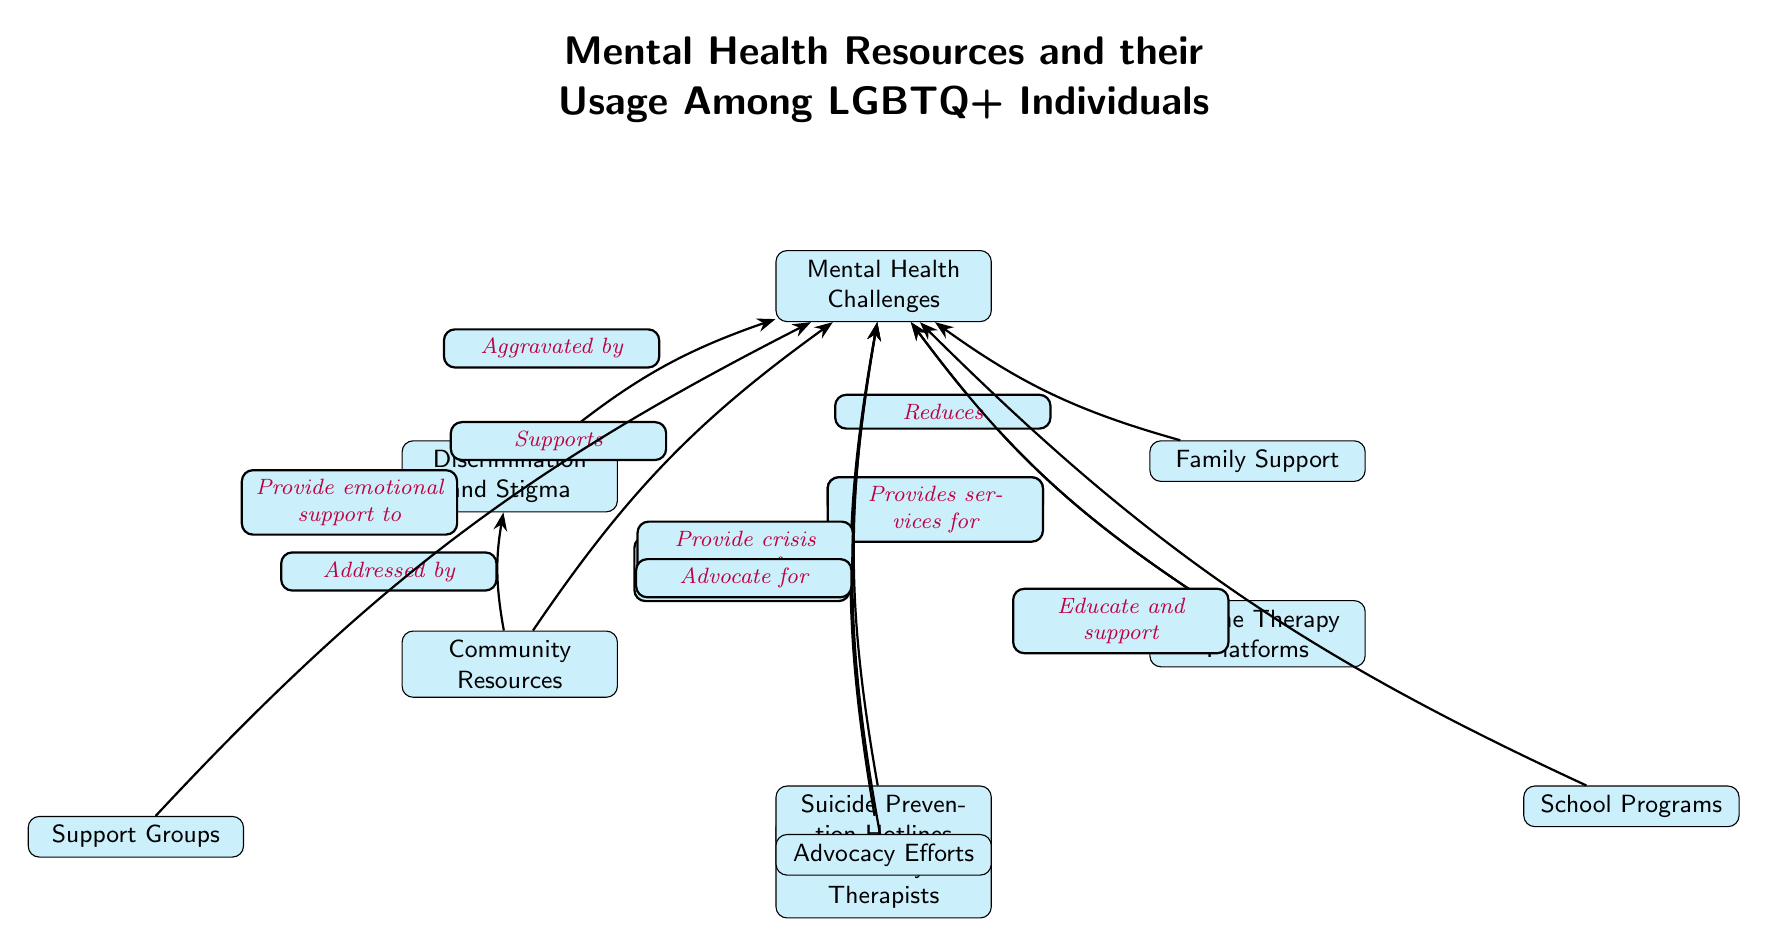What is the main topic of the diagram? The main topic of the diagram is indicated at the top, stating "Mental Health Resources and their Usage Among LGBTQ+ Individuals."
Answer: Mental Health Resources and their Usage Among LGBTQ+ Individuals How many nodes are there in the diagram? By counting the nodes listed in the diagram, we find a total of 10 distinct nodes.
Answer: 10 What does "Discrimination and Stigma" do to mental health challenges? The arrow shows that "Discrimination and Stigma" is connected to "Mental Health Challenges" with the relationship labeled as "Aggravated by," indicating its negative impact.
Answer: Aggravated by Which node supports "Mental Health Challenges" by providing crisis support? The node labeled "Suicide Prevention Hotlines" provides crisis support as indicated by the edge labeled "Provide crisis support for."
Answer: Suicide Prevention Hotlines What type of resources does "Community Resources" provide? "Community Resources" is shown as addressing mental health challenges, indicating a supportive relationship, which encompasses various types of assistance and programs.
Answer: Addressed by How does "Family Support" relate to mental health challenges? The relation is that "Family Support" is shown to reduce the impact of "Mental Health Challenges," suggesting that strong family backing can alleviate these challenges.
Answer: Reduces Which resource educates and supports those facing mental health challenges? "School Programs" is indicated to educate and support individuals facing mental health challenges as shown by the connection labeled accordingly.
Answer: School Programs What are the two types of therapy platforms mentioned? "Online Therapy Platforms" is listed, and under it, "LGBTQ+ Friendly Therapists" is a type of therapy mentioned, showing two distinct avenues for therapeutic help.
Answer: Online Therapy Platforms and LGBTQ+ Friendly Therapists What is the relationship between "Advocacy Efforts" and mental health challenges? "Advocacy Efforts" is shown to advocate for the mental health challenges, illustrating a support mechanism for raising awareness and promoting rights.
Answer: Advocate for 